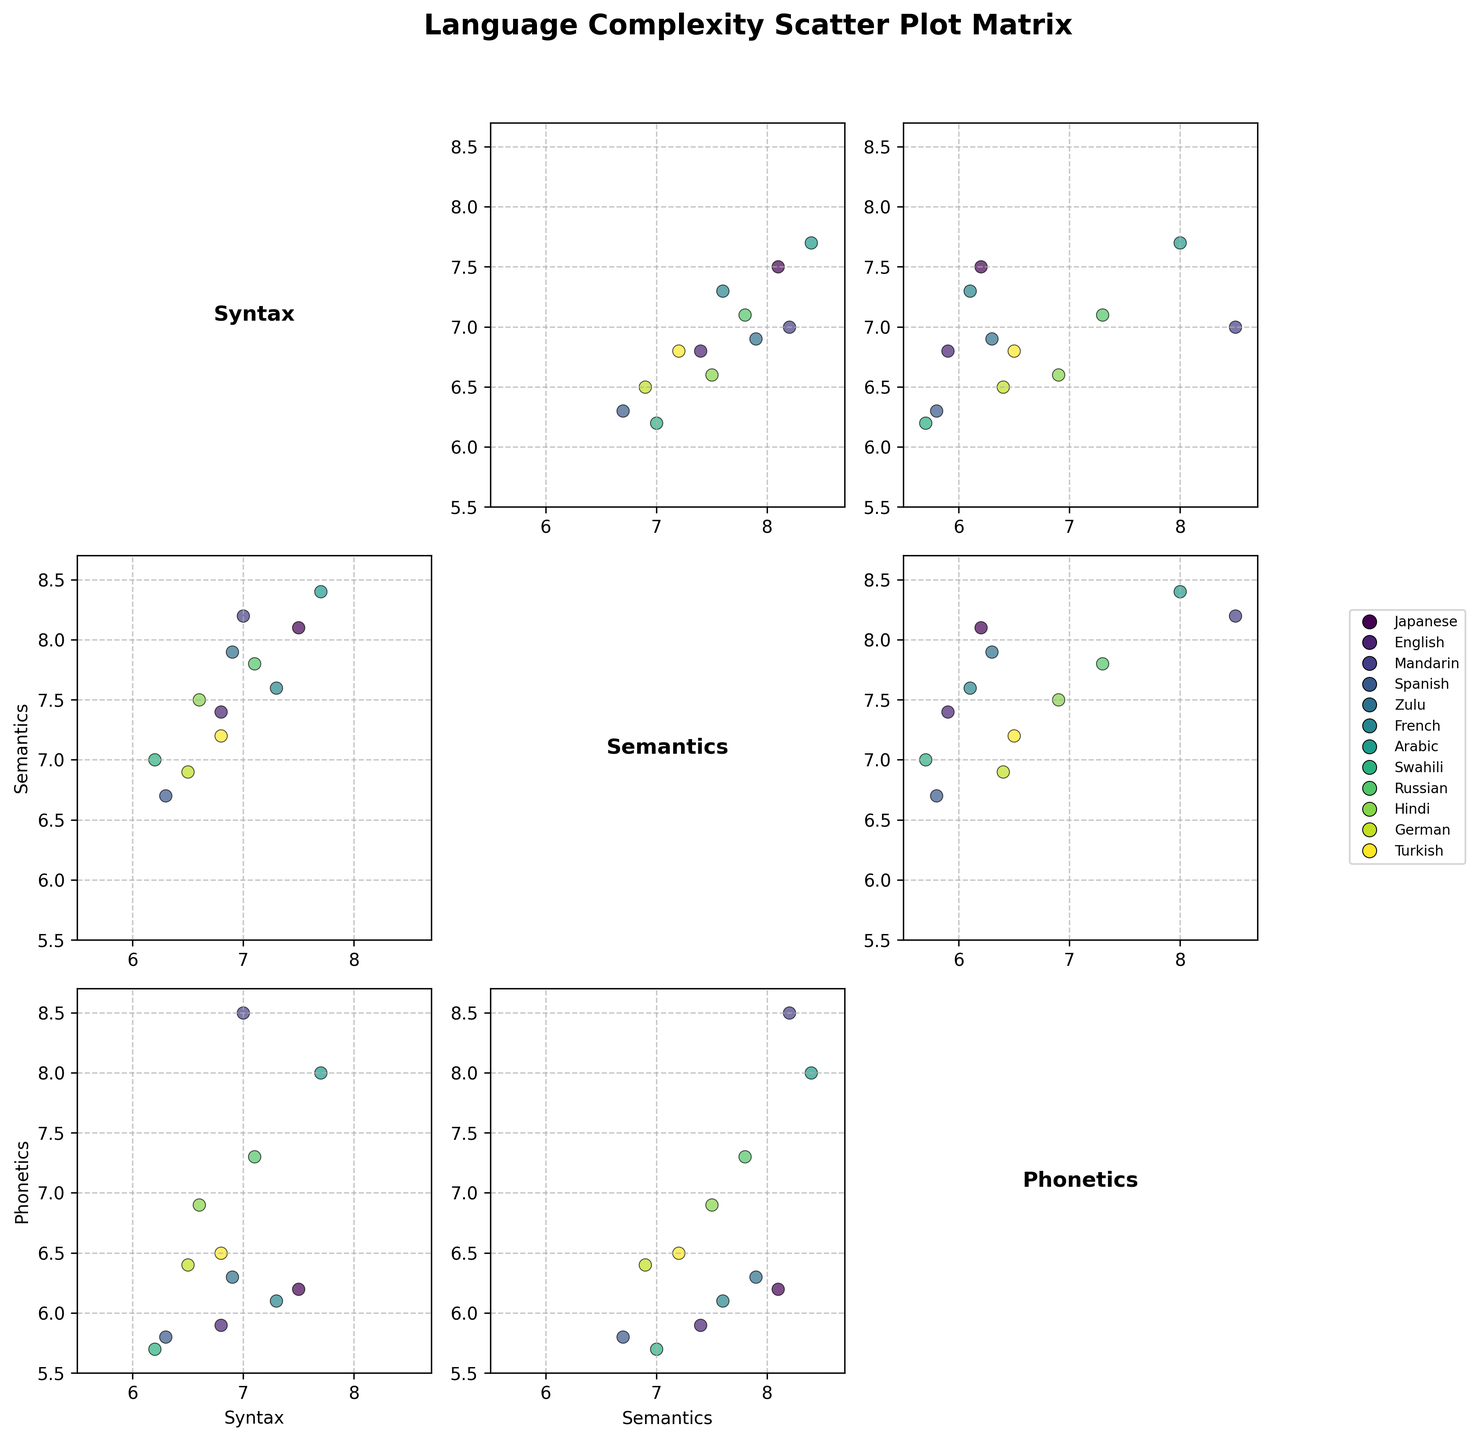What are the three variables analyzed in the Scatter Plot Matrix? The variables are typically labeled on the axes of each scatter plot in the SPLOM. In this case, the title and axes will show that the variables are Syntax, Semantics, and Phonetics Complexity.
Answer: Syntax, Semantics, Phonetics Which culture has the highest Syntax Complexity? By examining the scatter plots, you'll see that Arabic has the highest value for Syntax Complexity, as it has a point at the upper range of the Syntax axis.
Answer: Arabic Is there a visible positive correlation between Semantics Complexity and Syntax Complexity? You can determine this by looking at the scatter plot where Semantics Complexity is on one axis and Syntax Complexity is on the other. The points should form an upward trend if there's a positive correlation.
Answer: Yes Among the cultures plotted, which two have the lowest Phonetics Complexity? To identify this, look at the scatter plot matrix where Phonetics Complexity is on one of the axes. The lowest values are for Spanish and Swahili.
Answer: Spanish, Swahili How does the Phonetics Complexity of Mandarin compare to German? Find both Mandarin and German on the scatter plot matrix where Phonetics Complexity is plotted. Mandarin has a much higher Phonetics Complexity compared to German.
Answer: Mandarin is higher Which scatter plot shows the relationship between Syntax Complexity and Phonetics Complexity? Identify the plot where one axis is labeled as Syntax and the other as Phonetics. This plot will visualize the relationship between these two variables.
Answer: The one with Syntax on one axis and Phonetics on the other Which culture appears to have the most balanced complexity across all three variables? A balanced complexity would mean all values are relatively centered rather than at extremes. Russian shows values in a more central region for all three variables.
Answer: Russian What trend do you observe between Semantics and Phonetics Complexity? Look for a pattern in the scatter plot where Semantics is one axis and Phonetics the other. The points seem to cluster in an upward trend, indicating a positive correlation.
Answer: Positive correlation Who has a higher Semantics Complexity, French or Hindi? By locating French and Hindi on the Semantics Complexity axis, it can be determined that French has a slightly higher Semantics Complexity than Hindi.
Answer: French 